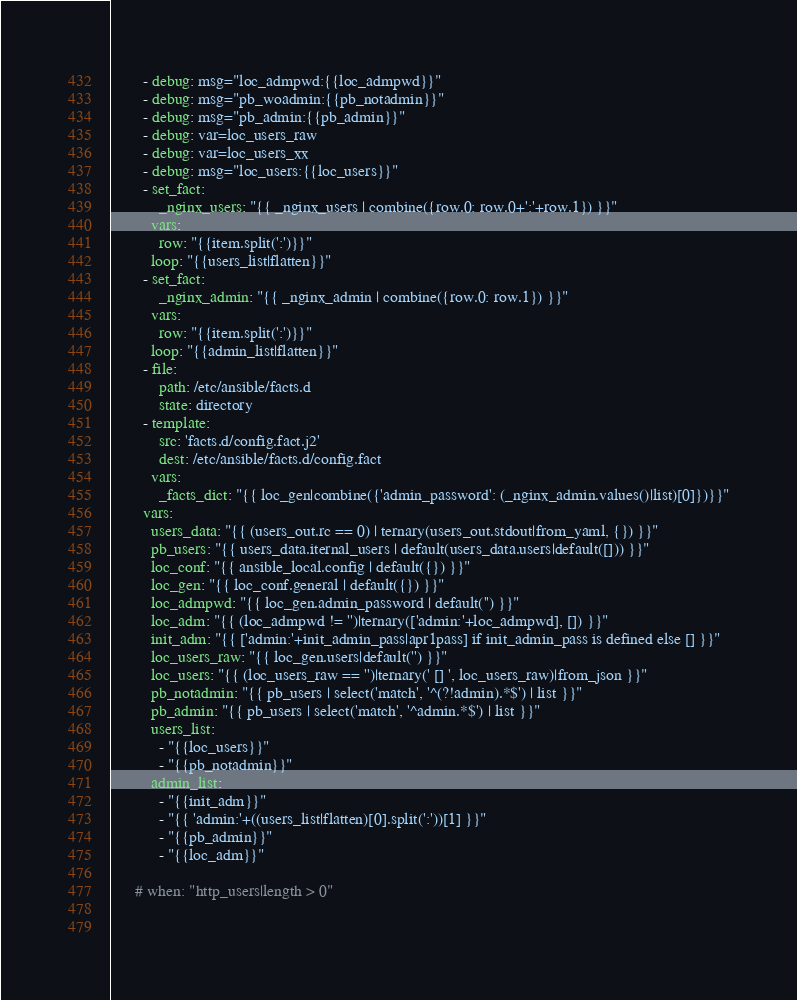<code> <loc_0><loc_0><loc_500><loc_500><_YAML_>        - debug: msg="loc_admpwd:{{loc_admpwd}}"
        - debug: msg="pb_woadmin:{{pb_notadmin}}"
        - debug: msg="pb_admin:{{pb_admin}}"
        - debug: var=loc_users_raw
        - debug: var=loc_users_xx
        - debug: msg="loc_users:{{loc_users}}"
        - set_fact:
            _nginx_users: "{{ _nginx_users | combine({row.0: row.0+':'+row.1}) }}"
          vars:
            row: "{{item.split(':')}}"
          loop: "{{users_list|flatten}}"
        - set_fact:
            _nginx_admin: "{{ _nginx_admin | combine({row.0: row.1}) }}"
          vars:
            row: "{{item.split(':')}}"
          loop: "{{admin_list|flatten}}"
        - file:
            path: /etc/ansible/facts.d
            state: directory
        - template:
            src: 'facts.d/config.fact.j2'
            dest: /etc/ansible/facts.d/config.fact
          vars:
            _facts_dict: "{{ loc_gen|combine({'admin_password': (_nginx_admin.values()|list)[0]})}}"
        vars:
          users_data: "{{ (users_out.rc == 0) | ternary(users_out.stdout|from_yaml, {}) }}"
          pb_users: "{{ users_data.iternal_users | default(users_data.users|default([])) }}"
          loc_conf: "{{ ansible_local.config | default({}) }}"
          loc_gen: "{{ loc_conf.general | default({}) }}"
          loc_admpwd: "{{ loc_gen.admin_password | default('') }}"
          loc_adm: "{{ (loc_admpwd != '')|ternary(['admin:'+loc_admpwd], []) }}"
          init_adm: "{{ ['admin:'+init_admin_pass|apr1pass] if init_admin_pass is defined else [] }}"
          loc_users_raw: "{{ loc_gen.users|default('') }}"
          loc_users: "{{ (loc_users_raw == '')|ternary(' [] ', loc_users_raw)|from_json }}"
          pb_notadmin: "{{ pb_users | select('match', '^(?!admin).*$') | list }}"
          pb_admin: "{{ pb_users | select('match', '^admin.*$') | list }}"
          users_list:
            - "{{loc_users}}"
            - "{{pb_notadmin}}"
          admin_list:
            - "{{init_adm}}"
            - "{{ 'admin:'+((users_list|flatten)[0].split(':'))[1] }}"
            - "{{pb_admin}}"
            - "{{loc_adm}}"          

      # when: "http_users|length > 0"
      
    </code> 